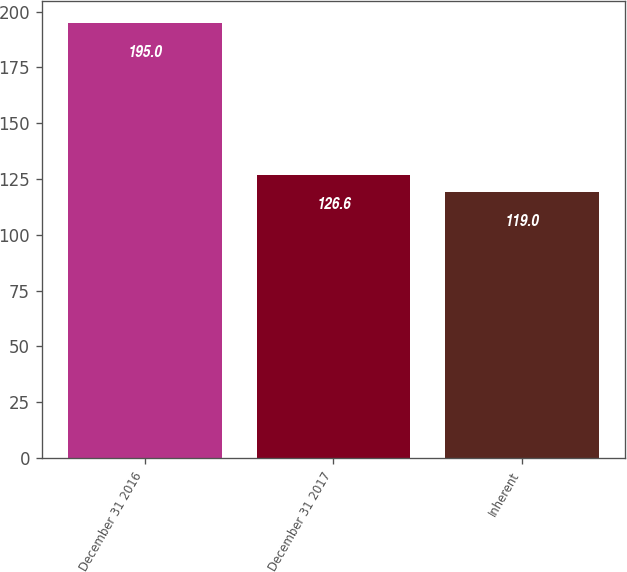Convert chart. <chart><loc_0><loc_0><loc_500><loc_500><bar_chart><fcel>December 31 2016<fcel>December 31 2017<fcel>Inherent<nl><fcel>195<fcel>126.6<fcel>119<nl></chart> 